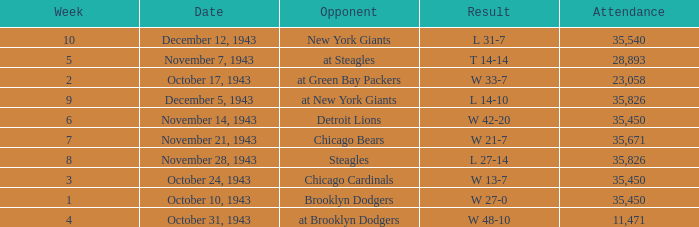Write the full table. {'header': ['Week', 'Date', 'Opponent', 'Result', 'Attendance'], 'rows': [['10', 'December 12, 1943', 'New York Giants', 'L 31-7', '35,540'], ['5', 'November 7, 1943', 'at Steagles', 'T 14-14', '28,893'], ['2', 'October 17, 1943', 'at Green Bay Packers', 'W 33-7', '23,058'], ['9', 'December 5, 1943', 'at New York Giants', 'L 14-10', '35,826'], ['6', 'November 14, 1943', 'Detroit Lions', 'W 42-20', '35,450'], ['7', 'November 21, 1943', 'Chicago Bears', 'W 21-7', '35,671'], ['8', 'November 28, 1943', 'Steagles', 'L 27-14', '35,826'], ['3', 'October 24, 1943', 'Chicago Cardinals', 'W 13-7', '35,450'], ['1', 'October 10, 1943', 'Brooklyn Dodgers', 'W 27-0', '35,450'], ['4', 'October 31, 1943', 'at Brooklyn Dodgers', 'W 48-10', '11,471']]} What is the lowest attendance that has a week less than 4, and w 13-7 as the result? 35450.0. 